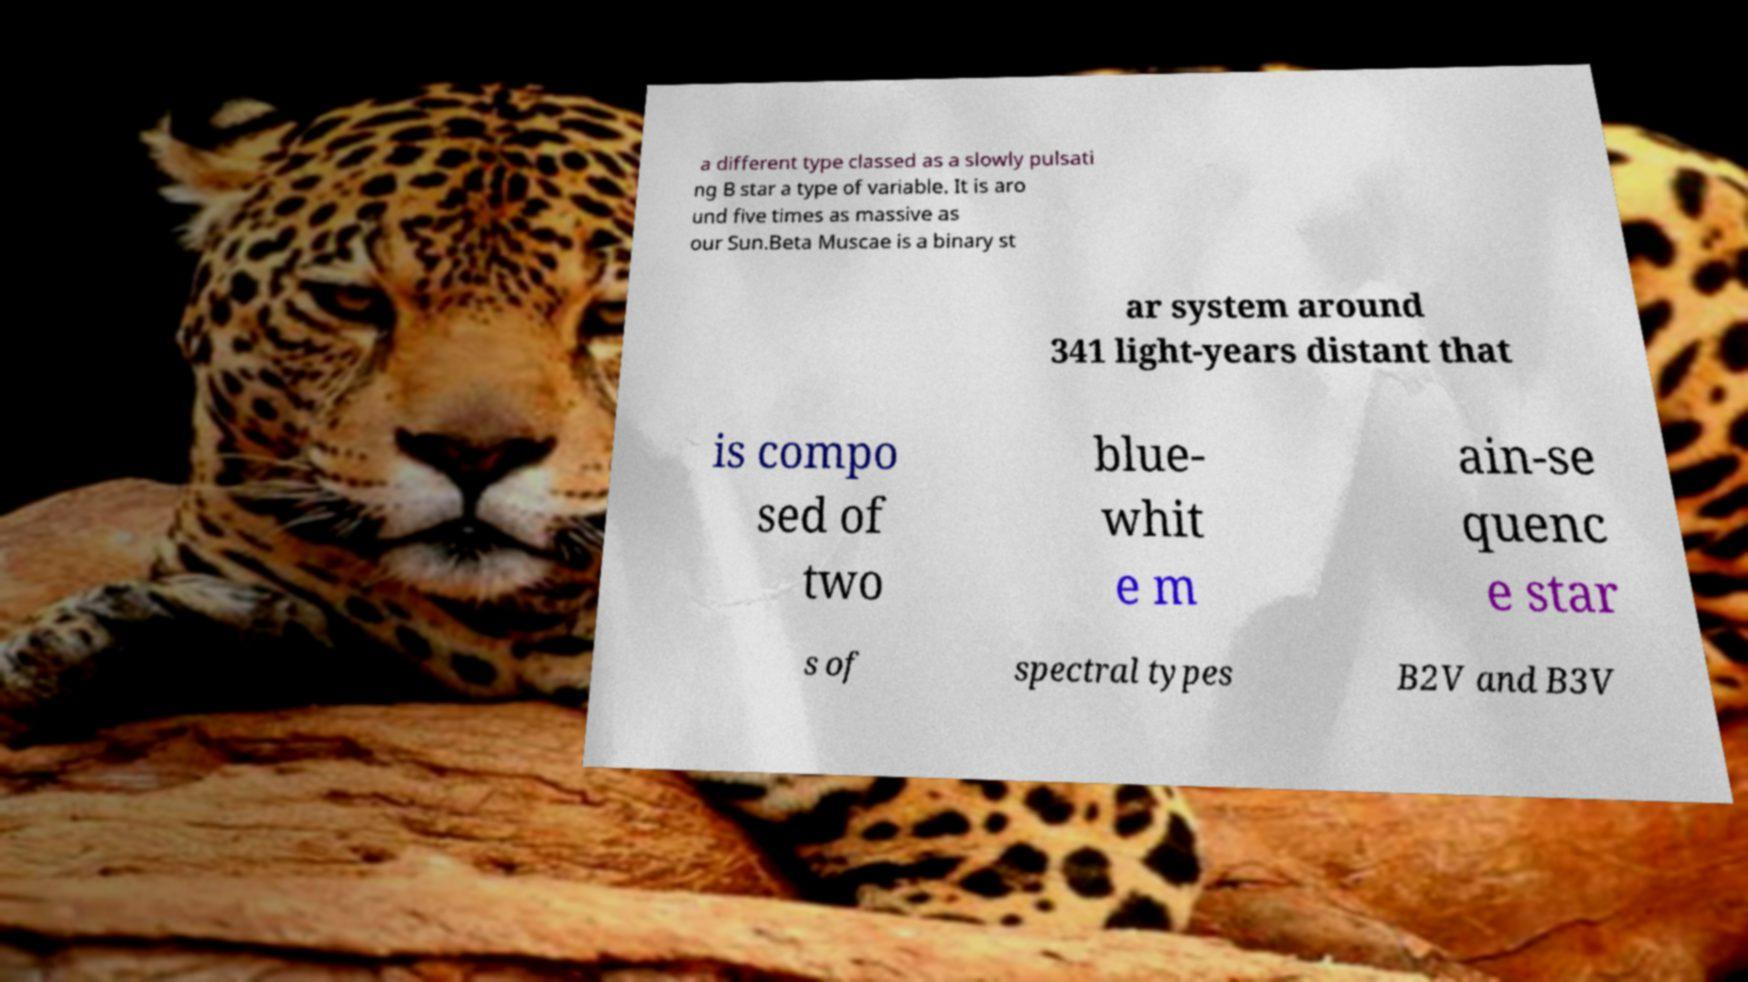Could you extract and type out the text from this image? a different type classed as a slowly pulsati ng B star a type of variable. It is aro und five times as massive as our Sun.Beta Muscae is a binary st ar system around 341 light-years distant that is compo sed of two blue- whit e m ain-se quenc e star s of spectral types B2V and B3V 